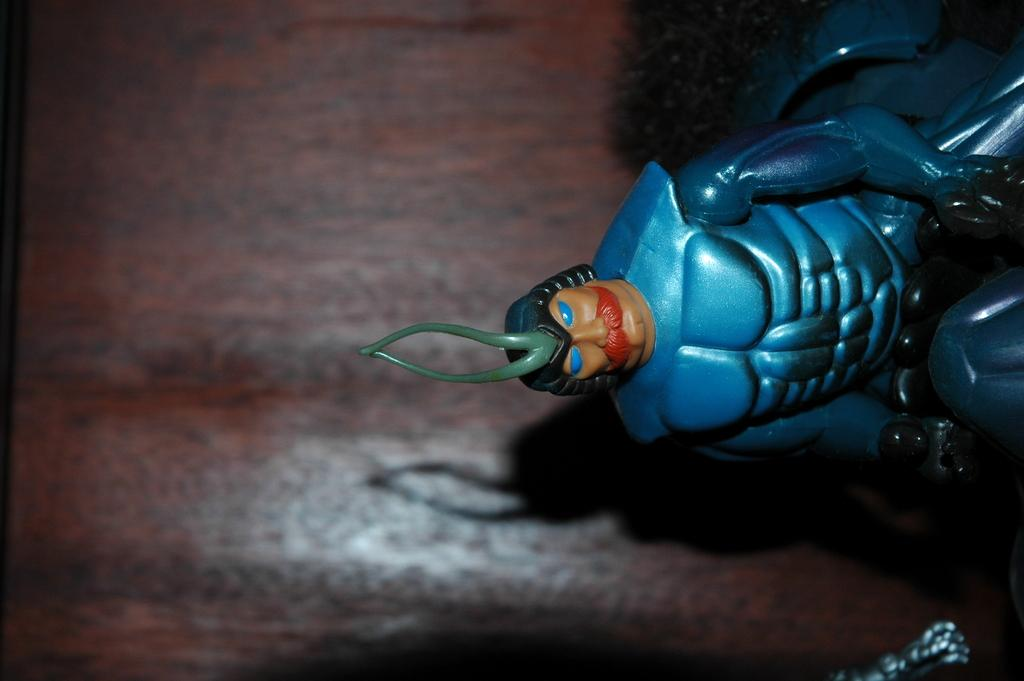What type of toy is visible in the image? There is a blue color toy in the image. How would you describe the background of the image? The background of the image is blurred. What color is the background of the image? The background color is brown. What type of watch can be seen on the toy in the image? There is no watch present on the toy in the image. How does the steam escape from the toy in the image? There is no steam present in the image, as it is a toy and not a steam-producing object. 